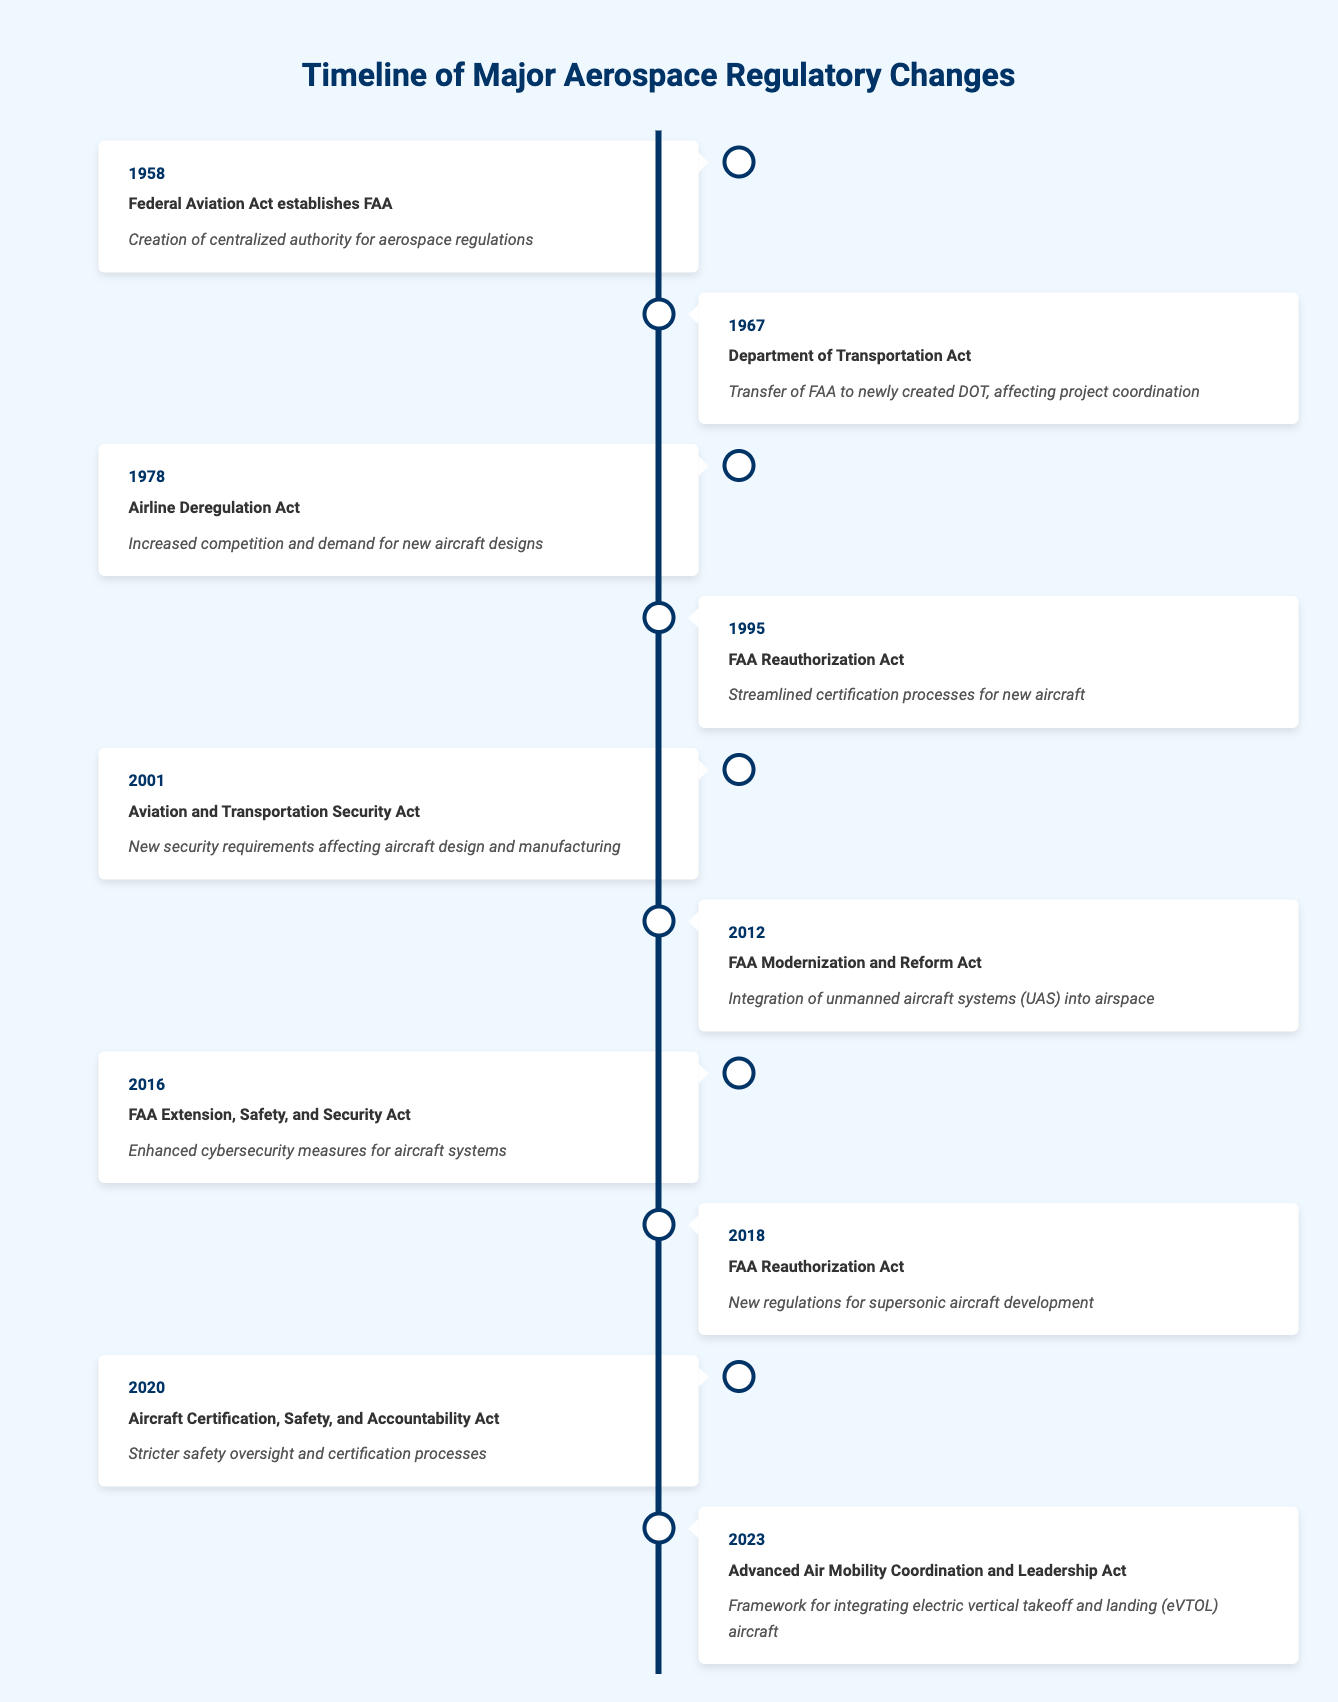What major regulatory event happened in 2001? The event listed for the year 2001 is the "Aviation and Transportation Security Act," which introduced new security requirements affecting aircraft design and manufacturing.
Answer: Aviation and Transportation Security Act What is the impact of the FAA Modernization and Reform Act of 2012? The impact listed for the FAA Modernization and Reform Act of 2012 is the "Integration of unmanned aircraft systems (UAS) into airspace."
Answer: Integration of unmanned aircraft systems into airspace How many years are there between the establishment of the FAA and the introduction of the Airline Deregulation Act? The FAA was established in 1958, and the Airline Deregulation Act was introduced in 1978. The difference is 1978 - 1958 = 20 years.
Answer: 20 years Is the FAA Reauthorization Act related to the certification processes for new aircraft? Yes, the FAA Reauthorization Act, specifically in 1995, is stated to have streamlined certification processes for new aircraft, confirming its relevance.
Answer: Yes Which event led to the transfer of the FAA to the newly created Department of Transportation? The event that led to the transfer of the FAA was the "Department of Transportation Act" in 1967.
Answer: Department of Transportation Act What is the total number of events listed from the FAA establishment in 1958 to 2023? The timeline lists a total of 10 events between 1958 and 2023. Counting them all gives us 10 events.
Answer: 10 events What regulatory change occurred regarding cybersecurity in the aerospace industry? The "FAA Extension, Safety, and Security Act" in 2016 implemented enhanced cybersecurity measures for aircraft systems, representing a significant change in safety regulations.
Answer: Enhanced cybersecurity measures for aircraft systems Between which years did the FAA Reauthorization Act occur multiple times? The FAA Reauthorization Act occurred in 1995 and again in 2018; both years indicate the act's recurring importance in regulatory changes.
Answer: 1995 and 2018 What is the potential impact of the Advanced Air Mobility Coordination and Leadership Act? The Act, introduced in 2023, provides a framework for integrating electric vertical takeoff and landing (eVTOL) aircraft, influencing future project planning in aerospace.
Answer: Framework for integrating eVTOL aircraft 